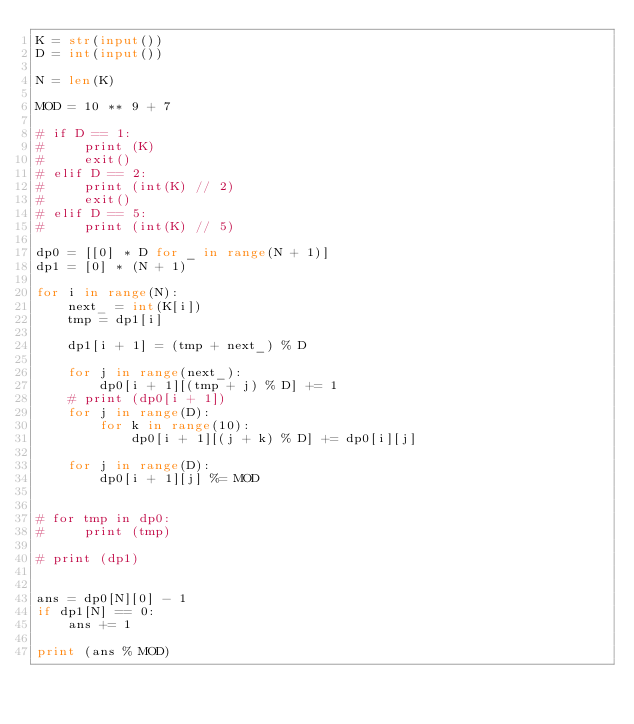<code> <loc_0><loc_0><loc_500><loc_500><_Python_>K = str(input())
D = int(input())

N = len(K)

MOD = 10 ** 9 + 7

# if D == 1:
#     print (K)
#     exit()
# elif D == 2:
#     print (int(K) // 2)
#     exit()
# elif D == 5:
#     print (int(K) // 5)

dp0 = [[0] * D for _ in range(N + 1)]
dp1 = [0] * (N + 1)

for i in range(N):
    next_ = int(K[i])
    tmp = dp1[i]

    dp1[i + 1] = (tmp + next_) % D
    
    for j in range(next_):
        dp0[i + 1][(tmp + j) % D] += 1
    # print (dp0[i + 1])
    for j in range(D):
        for k in range(10):
            dp0[i + 1][(j + k) % D] += dp0[i][j]
    
    for j in range(D):
        dp0[i + 1][j] %= MOD


# for tmp in dp0:
#     print (tmp)

# print (dp1)


ans = dp0[N][0] - 1
if dp1[N] == 0:
    ans += 1

print (ans % MOD)</code> 